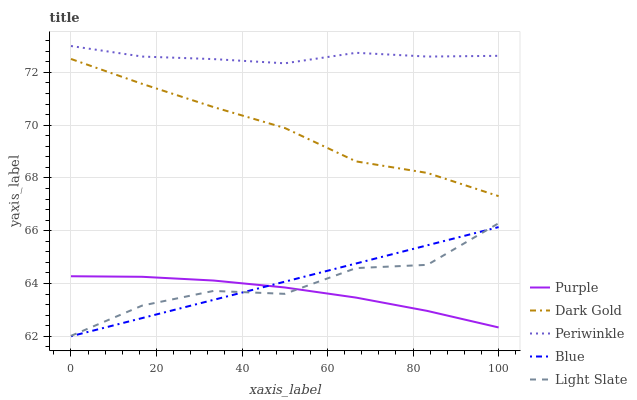Does Purple have the minimum area under the curve?
Answer yes or no. Yes. Does Periwinkle have the maximum area under the curve?
Answer yes or no. Yes. Does Blue have the minimum area under the curve?
Answer yes or no. No. Does Blue have the maximum area under the curve?
Answer yes or no. No. Is Blue the smoothest?
Answer yes or no. Yes. Is Light Slate the roughest?
Answer yes or no. Yes. Is Periwinkle the smoothest?
Answer yes or no. No. Is Periwinkle the roughest?
Answer yes or no. No. Does Blue have the lowest value?
Answer yes or no. Yes. Does Periwinkle have the lowest value?
Answer yes or no. No. Does Periwinkle have the highest value?
Answer yes or no. Yes. Does Blue have the highest value?
Answer yes or no. No. Is Light Slate less than Periwinkle?
Answer yes or no. Yes. Is Periwinkle greater than Dark Gold?
Answer yes or no. Yes. Does Light Slate intersect Blue?
Answer yes or no. Yes. Is Light Slate less than Blue?
Answer yes or no. No. Is Light Slate greater than Blue?
Answer yes or no. No. Does Light Slate intersect Periwinkle?
Answer yes or no. No. 